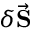Convert formula to latex. <formula><loc_0><loc_0><loc_500><loc_500>\delta \vec { \mathbf S }</formula> 